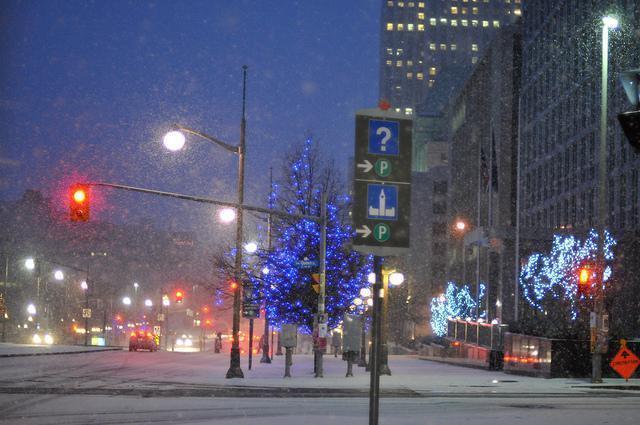Why have they made the trees blue?
Select the accurate response from the four choices given to answer the question.
Options: Visibility, attract pollinators, protect leaves, holidays. Holidays. 